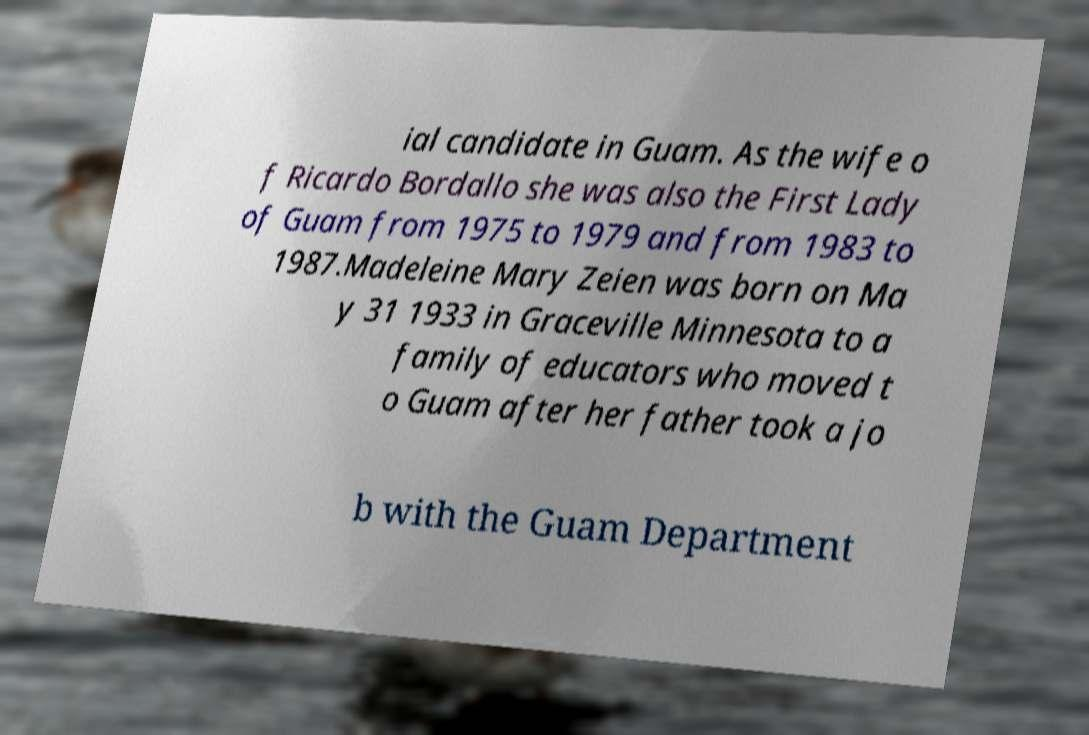For documentation purposes, I need the text within this image transcribed. Could you provide that? ial candidate in Guam. As the wife o f Ricardo Bordallo she was also the First Lady of Guam from 1975 to 1979 and from 1983 to 1987.Madeleine Mary Zeien was born on Ma y 31 1933 in Graceville Minnesota to a family of educators who moved t o Guam after her father took a jo b with the Guam Department 